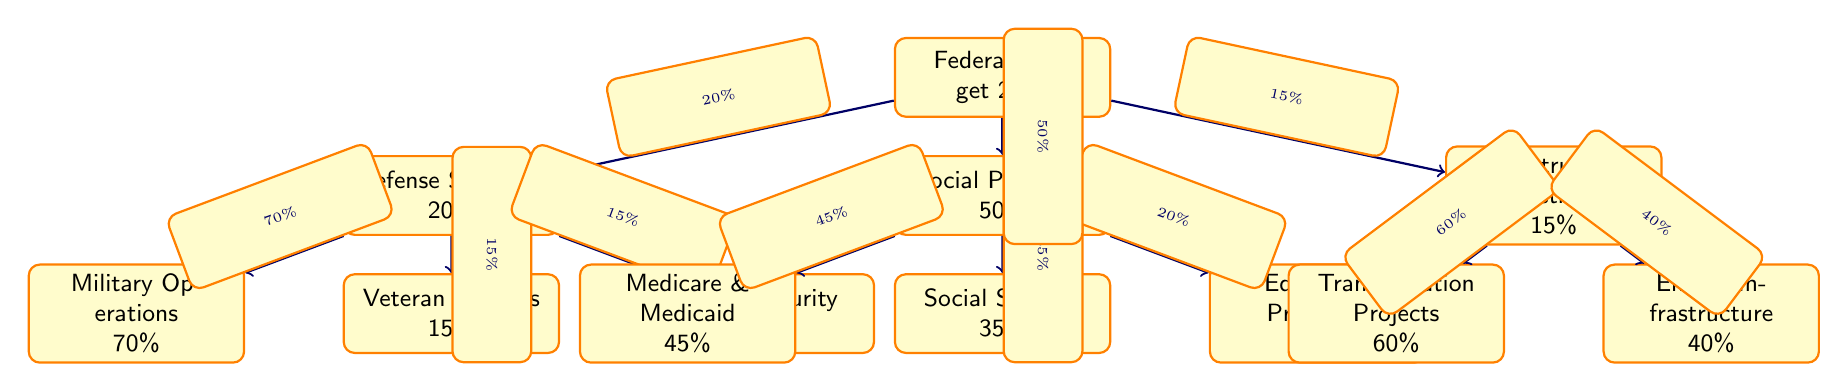What percentage of the federal budget is allocated for social programs? By looking at the main node labeled "Social Programs" in the diagram, we can see that it indicates 50% of the total federal budget is designated for this category.
Answer: 50% What is the largest portion of spending within the defense category? Within the "Defense Spending" node, we examine its child nodes. The "Military Operations" node denotes that it constitutes 70% of the defense spending, making it the largest portion in this category.
Answer: 70% How much of the infrastructure investment is allocated to transportation projects? The "Transportation Projects" child node under the "Infrastructure Investment" shows that it accounts for 60% of this particular investment.
Answer: 60% What percentage of social programs spending is allocated to Medicare and Medicaid? Looking at the "Medicare & Medicaid" child node under "Social Programs," we find it states that 45% of the social programs spending is directed to it.
Answer: 45% What is the total percentage allocated to defense spending and infrastructure investment combined? First, we identify the percentages for each category: "Defense Spending" is 20% and "Infrastructure Investment" is 15%. Adding these two percentages together gives us 20% + 15% = 35%.
Answer: 35% Which category of spending has the least allocation in the federal budget? By examining the main nodes, we see that "Infrastructure Investment" represents the smallest allocation at 15%, which is less than both defense spending and social programs.
Answer: 15% What percentage of social programs is dedicated to education programs? From the "Social Programs" node, we can see that the "Education Programs" child node represents 20% of the social programs expenditure.
Answer: 20% Which two categories together account for more than 75% of the federal budget? By summing the portions allocated, "Social Programs" (50%) and "Defense Spending" (20%) total 70%. The only combination that surpasses 75% is "Social Programs" (50%) and "Infrastructure Investment" (15%), providing a combined total of 65%, hence no two categories exceed 75%. The next best combination would be "Social Programs" and a portion of Defense Spending, thus remaining below 75%.
Answer: No What is the total number of child nodes in the diagram? To find the total number of child nodes, we count them under each main category: Defense Spending has 3 child nodes, Social Programs has 3 child nodes, and Infrastructure Investment has 2 child nodes. Adding these yields 3 + 3 + 2 = 8 child nodes in total.
Answer: 8 